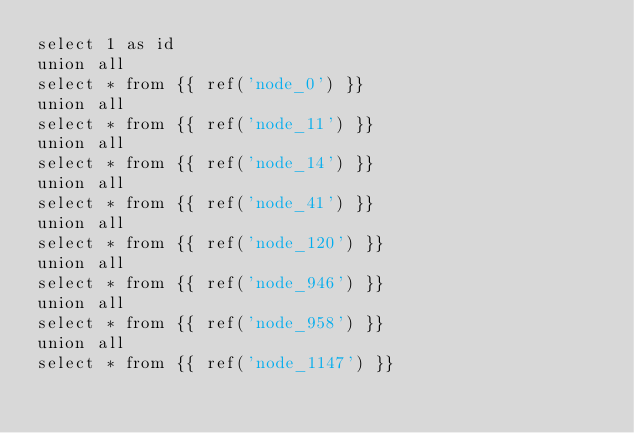<code> <loc_0><loc_0><loc_500><loc_500><_SQL_>select 1 as id
union all
select * from {{ ref('node_0') }}
union all
select * from {{ ref('node_11') }}
union all
select * from {{ ref('node_14') }}
union all
select * from {{ ref('node_41') }}
union all
select * from {{ ref('node_120') }}
union all
select * from {{ ref('node_946') }}
union all
select * from {{ ref('node_958') }}
union all
select * from {{ ref('node_1147') }}
</code> 